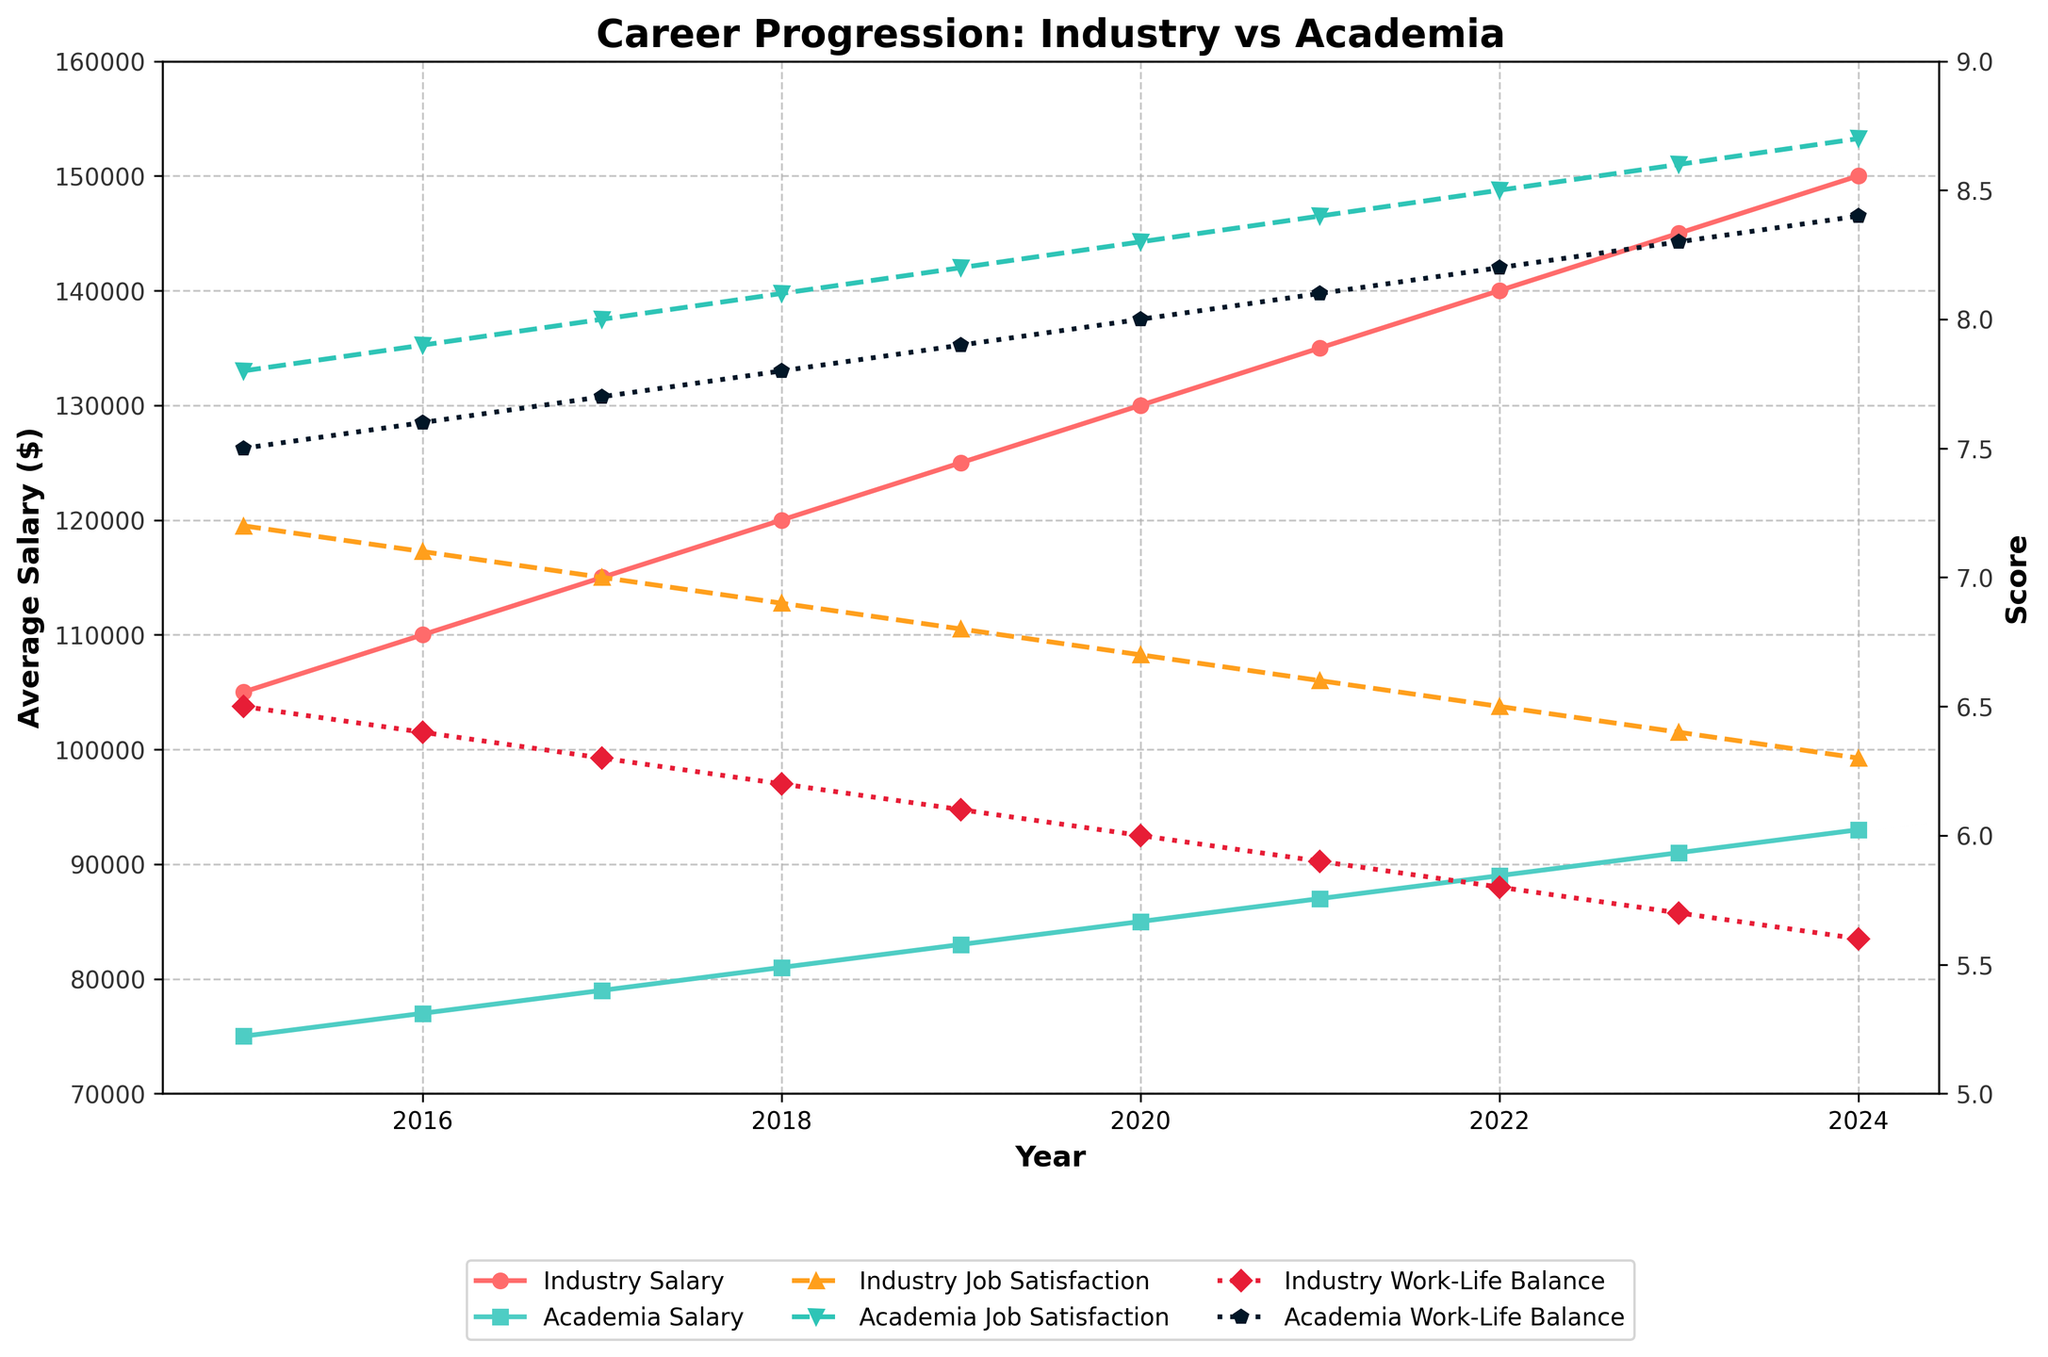what is the difference in the industry and academia average salaries for the year 2023? To find the difference, subtract the academia average salary from the industry average salary for the year 2023. The industry average salary is $145,000 and the academia average salary is $91,000. So, $145,000 - $91,000 = $54,000.
Answer: $54,000 How does the trend of job satisfaction in academia compare to that in the industry from 2015 to 2024? In the plot, the job satisfaction in academia consistently increases from 7.8 in 2015 to 8.7 in 2024. In contrast, the job satisfaction in industry decreases from 7.2 in 2015 to 6.3 in 2024. This shows that job satisfaction in academia is improving while it is declining in the industry.
Answer: Academia increases, Industry decreases Which year shows the smallest gap in work-life balance between industry and academia? By inspecting the plot, the smallest gap in work-life balance between industry and academia occurs in 2015, where the gap is 7.5 (academia) - 6.5 (industry) = 1.0 point.
Answer: 2015 What is the average job satisfaction in academia over the period shown? To calculate the average, add all the job satisfaction scores for academia and divide by the number of years. (7.8 + 7.9 + 8.0 + 8.1 + 8.2 + 8.3 + 8.4 + 8.5 + 8.6 + 8.7) / 10 = 8.15.
Answer: 8.15 In which year is the gap between the average salaries of industry and academia the highest? By checking for the largest difference between the industry and academia salaries through the years on the plot, the largest gap occurs in 2024 since $150,000 (industry) - $93,000 (academia) = $57,000.
Answer: 2024 Is the work-life balance in academia always better than in the industry throughout the years 2015 to 2024? By inspecting the plot's lines representing work-life balance, the work-life balance score for academia is consistently higher than that of the industry every year from 2015 to 2024.
Answer: Yes What is the total increase in job satisfaction in academia from 2015 to 2024? To find the total increase, subtract the job satisfaction score in 2015 from the score in 2024. The score in 2024 is 8.7, and in 2015 it is 7.8. So, 8.7 - 7.8 = 0.9.
Answer: 0.9 How does the slope of the average salaries in industry compare to that in academia from 2015 to 2024? The slope is calculated by the change in salary over the years. For industry: ($150,000 - $105,000) / (2024 - 2015) = $5000/year. For academia: ($93,000 - $75,000) / (2024 - 2015) = $1800/year. The slope of the industry salary line is steeper than that of the academia salary line, indicating a faster increase in industry salaries.
Answer: Industry slope is steeper 